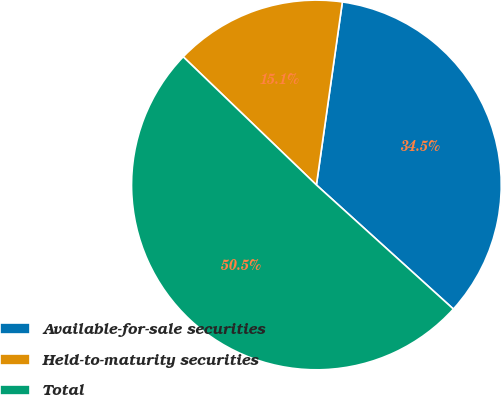Convert chart. <chart><loc_0><loc_0><loc_500><loc_500><pie_chart><fcel>Available-for-sale securities<fcel>Held-to-maturity securities<fcel>Total<nl><fcel>34.47%<fcel>15.05%<fcel>50.48%<nl></chart> 